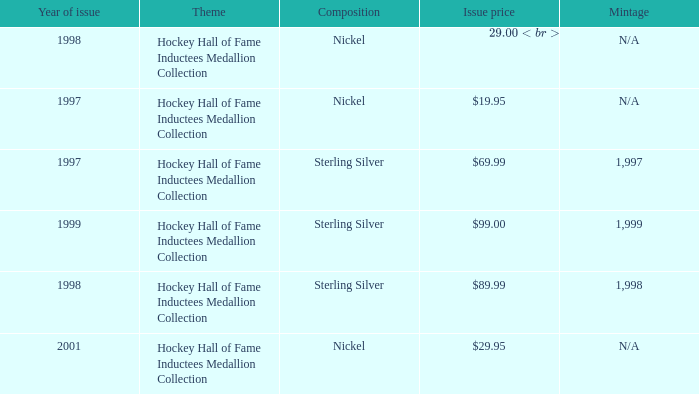How many years was the issue price $19.95? 1.0. 